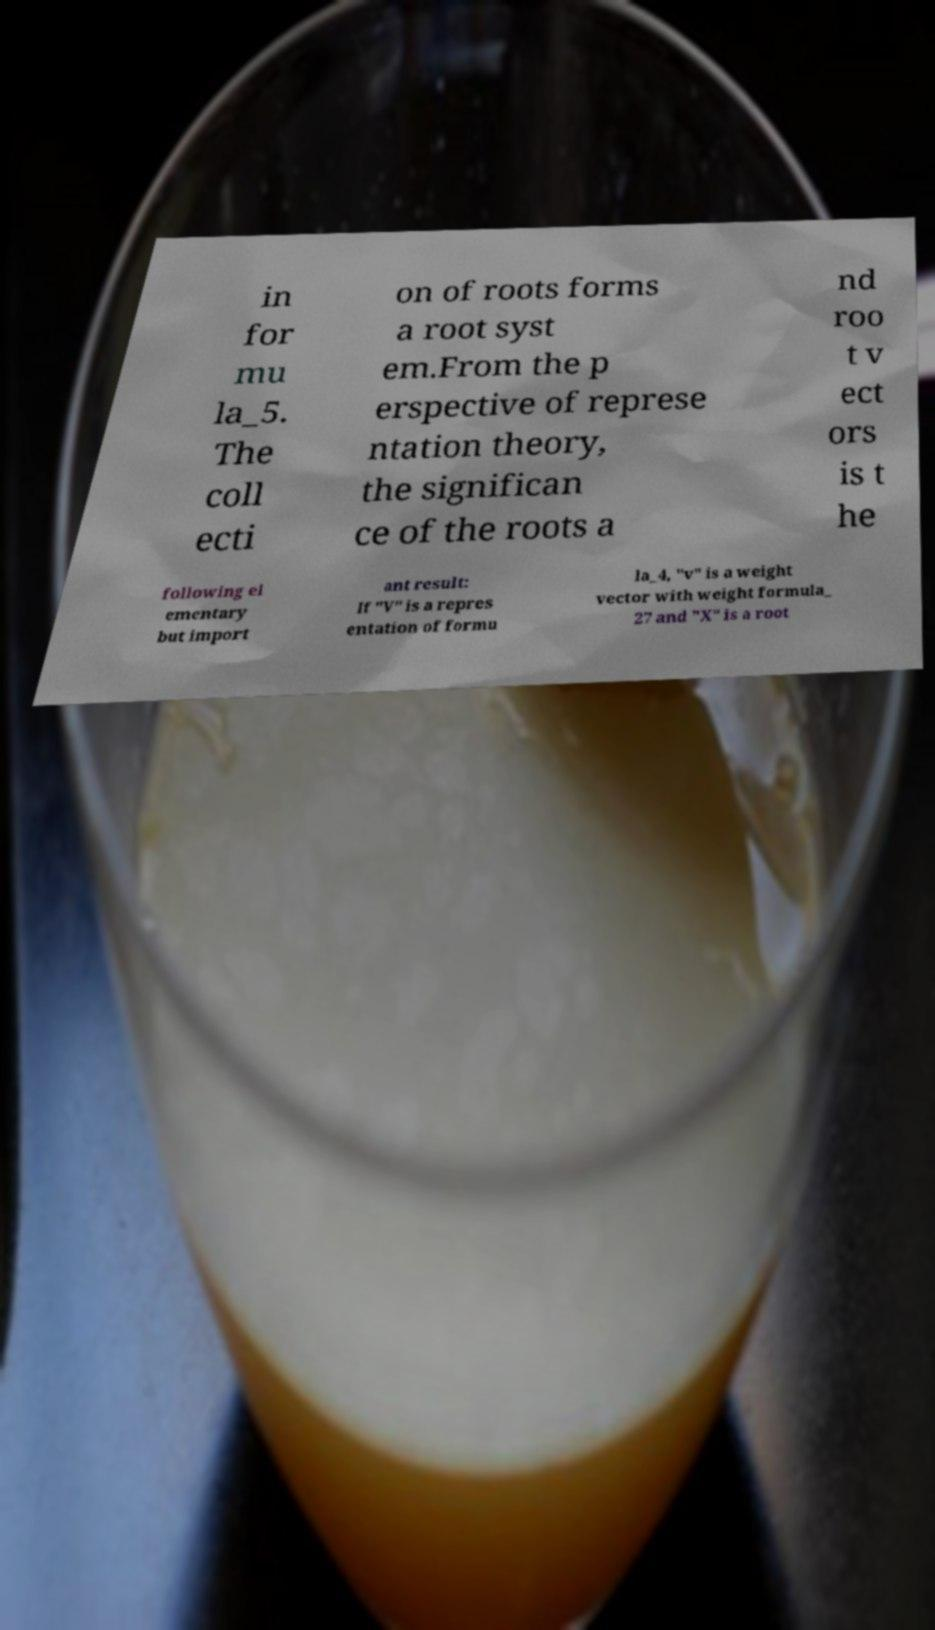Could you extract and type out the text from this image? in for mu la_5. The coll ecti on of roots forms a root syst em.From the p erspective of represe ntation theory, the significan ce of the roots a nd roo t v ect ors is t he following el ementary but import ant result: If "V" is a repres entation of formu la_4, "v" is a weight vector with weight formula_ 27 and "X" is a root 